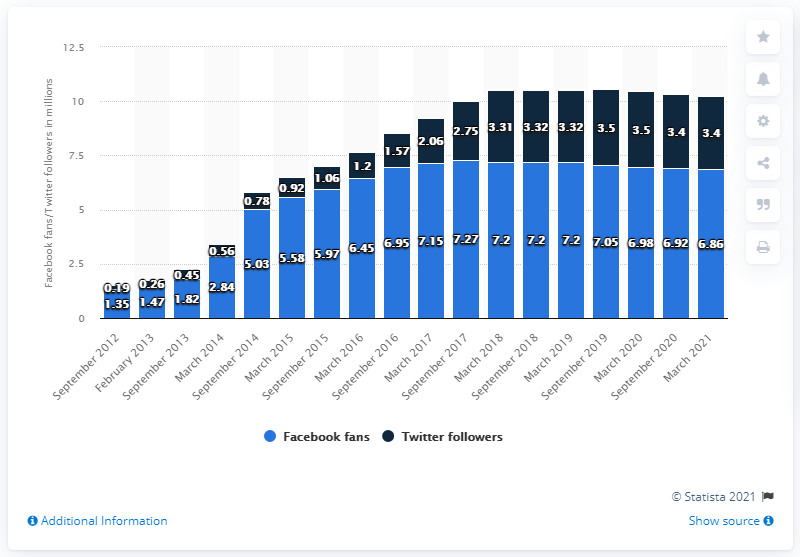Identify some key points in this picture. As of March 2021, the San Antonio Spurs basketball team had 6.86 million Facebook followers. 